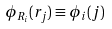<formula> <loc_0><loc_0><loc_500><loc_500>\phi _ { { R } _ { i } } ( { r } _ { j } ) \equiv \phi _ { i } ( j )</formula> 